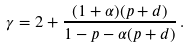<formula> <loc_0><loc_0><loc_500><loc_500>\gamma = 2 + \frac { ( 1 + \alpha ) ( p + d ) } { 1 - p - \alpha ( p + d ) } \, .</formula> 